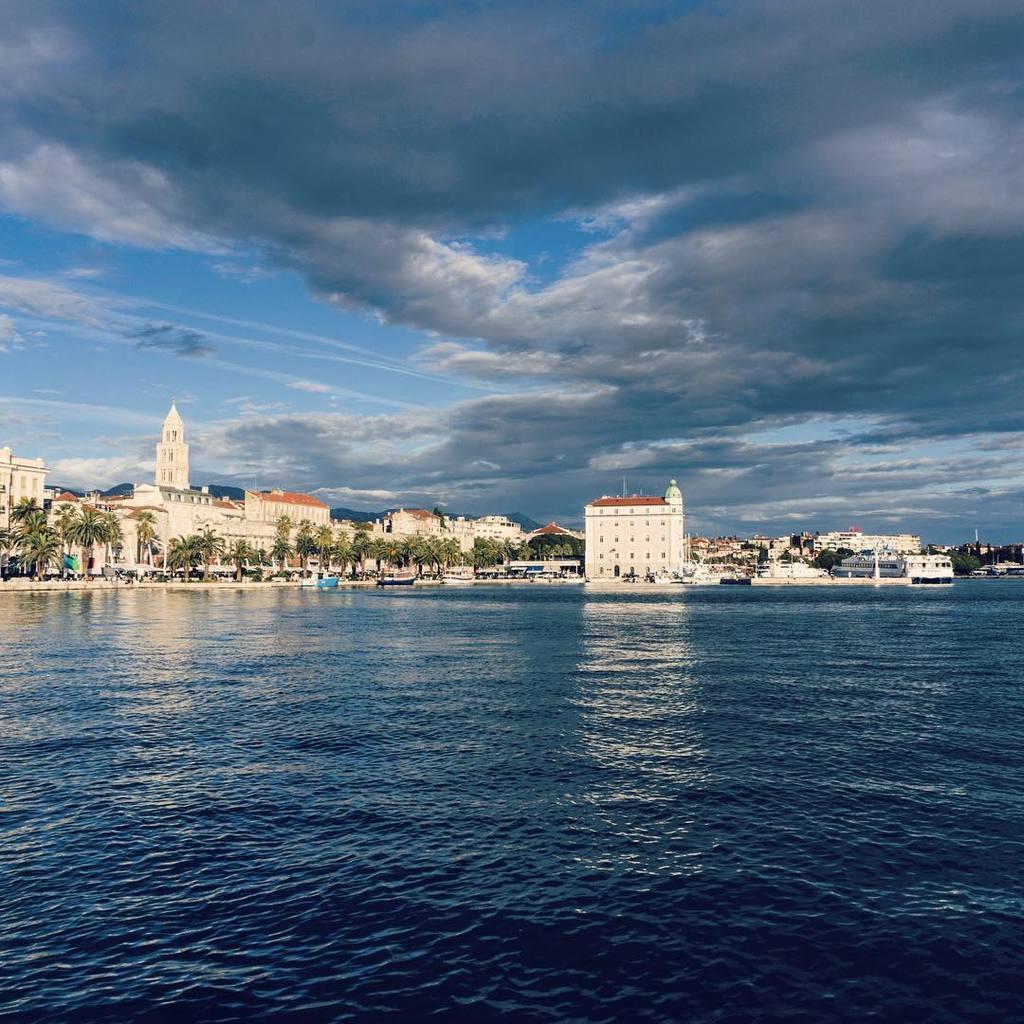Please provide a concise description of this image. In this picture I can see water and few buildings, trees and I can see a blue cloudy sky. 